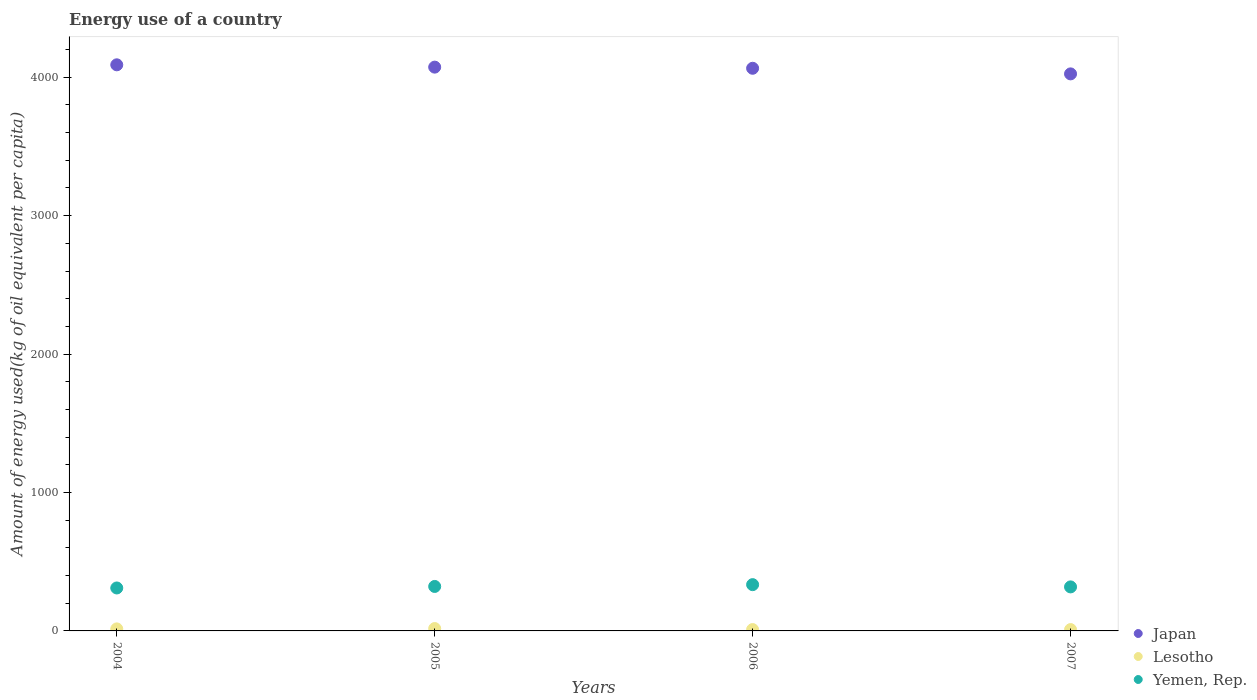How many different coloured dotlines are there?
Your answer should be very brief. 3. Is the number of dotlines equal to the number of legend labels?
Offer a terse response. Yes. What is the amount of energy used in in Lesotho in 2004?
Your answer should be compact. 14.64. Across all years, what is the maximum amount of energy used in in Lesotho?
Offer a terse response. 17.14. Across all years, what is the minimum amount of energy used in in Japan?
Your answer should be very brief. 4024.27. In which year was the amount of energy used in in Lesotho minimum?
Keep it short and to the point. 2007. What is the total amount of energy used in in Yemen, Rep. in the graph?
Your answer should be very brief. 1283.9. What is the difference between the amount of energy used in in Japan in 2005 and that in 2007?
Make the answer very short. 48.74. What is the difference between the amount of energy used in in Yemen, Rep. in 2004 and the amount of energy used in in Japan in 2007?
Your answer should be compact. -3713.97. What is the average amount of energy used in in Yemen, Rep. per year?
Your answer should be very brief. 320.97. In the year 2005, what is the difference between the amount of energy used in in Yemen, Rep. and amount of energy used in in Japan?
Offer a terse response. -3751.74. What is the ratio of the amount of energy used in in Japan in 2004 to that in 2007?
Offer a terse response. 1.02. Is the amount of energy used in in Lesotho in 2004 less than that in 2006?
Provide a short and direct response. No. What is the difference between the highest and the second highest amount of energy used in in Lesotho?
Ensure brevity in your answer.  2.49. What is the difference between the highest and the lowest amount of energy used in in Lesotho?
Give a very brief answer. 7.42. In how many years, is the amount of energy used in in Yemen, Rep. greater than the average amount of energy used in in Yemen, Rep. taken over all years?
Provide a succinct answer. 2. Does the amount of energy used in in Japan monotonically increase over the years?
Your answer should be compact. No. Is the amount of energy used in in Japan strictly greater than the amount of energy used in in Lesotho over the years?
Ensure brevity in your answer.  Yes. How many dotlines are there?
Keep it short and to the point. 3. What is the difference between two consecutive major ticks on the Y-axis?
Make the answer very short. 1000. Are the values on the major ticks of Y-axis written in scientific E-notation?
Offer a very short reply. No. Does the graph contain grids?
Provide a short and direct response. No. Where does the legend appear in the graph?
Your answer should be compact. Bottom right. How many legend labels are there?
Give a very brief answer. 3. What is the title of the graph?
Offer a very short reply. Energy use of a country. Does "Turkey" appear as one of the legend labels in the graph?
Your answer should be very brief. No. What is the label or title of the Y-axis?
Provide a succinct answer. Amount of energy used(kg of oil equivalent per capita). What is the Amount of energy used(kg of oil equivalent per capita) of Japan in 2004?
Offer a terse response. 4089.78. What is the Amount of energy used(kg of oil equivalent per capita) in Lesotho in 2004?
Your answer should be very brief. 14.64. What is the Amount of energy used(kg of oil equivalent per capita) in Yemen, Rep. in 2004?
Your response must be concise. 310.3. What is the Amount of energy used(kg of oil equivalent per capita) in Japan in 2005?
Offer a terse response. 4073.01. What is the Amount of energy used(kg of oil equivalent per capita) in Lesotho in 2005?
Ensure brevity in your answer.  17.14. What is the Amount of energy used(kg of oil equivalent per capita) of Yemen, Rep. in 2005?
Give a very brief answer. 321.27. What is the Amount of energy used(kg of oil equivalent per capita) in Japan in 2006?
Ensure brevity in your answer.  4064.75. What is the Amount of energy used(kg of oil equivalent per capita) of Lesotho in 2006?
Offer a very short reply. 9.79. What is the Amount of energy used(kg of oil equivalent per capita) in Yemen, Rep. in 2006?
Ensure brevity in your answer.  334.32. What is the Amount of energy used(kg of oil equivalent per capita) in Japan in 2007?
Ensure brevity in your answer.  4024.27. What is the Amount of energy used(kg of oil equivalent per capita) of Lesotho in 2007?
Offer a very short reply. 9.72. What is the Amount of energy used(kg of oil equivalent per capita) in Yemen, Rep. in 2007?
Provide a succinct answer. 318.01. Across all years, what is the maximum Amount of energy used(kg of oil equivalent per capita) in Japan?
Your answer should be compact. 4089.78. Across all years, what is the maximum Amount of energy used(kg of oil equivalent per capita) of Lesotho?
Your answer should be very brief. 17.14. Across all years, what is the maximum Amount of energy used(kg of oil equivalent per capita) in Yemen, Rep.?
Make the answer very short. 334.32. Across all years, what is the minimum Amount of energy used(kg of oil equivalent per capita) in Japan?
Your answer should be very brief. 4024.27. Across all years, what is the minimum Amount of energy used(kg of oil equivalent per capita) in Lesotho?
Your response must be concise. 9.72. Across all years, what is the minimum Amount of energy used(kg of oil equivalent per capita) in Yemen, Rep.?
Your answer should be compact. 310.3. What is the total Amount of energy used(kg of oil equivalent per capita) in Japan in the graph?
Offer a very short reply. 1.63e+04. What is the total Amount of energy used(kg of oil equivalent per capita) of Lesotho in the graph?
Offer a very short reply. 51.29. What is the total Amount of energy used(kg of oil equivalent per capita) in Yemen, Rep. in the graph?
Provide a succinct answer. 1283.9. What is the difference between the Amount of energy used(kg of oil equivalent per capita) in Japan in 2004 and that in 2005?
Your response must be concise. 16.77. What is the difference between the Amount of energy used(kg of oil equivalent per capita) in Lesotho in 2004 and that in 2005?
Give a very brief answer. -2.49. What is the difference between the Amount of energy used(kg of oil equivalent per capita) in Yemen, Rep. in 2004 and that in 2005?
Offer a very short reply. -10.97. What is the difference between the Amount of energy used(kg of oil equivalent per capita) of Japan in 2004 and that in 2006?
Your answer should be compact. 25.02. What is the difference between the Amount of energy used(kg of oil equivalent per capita) in Lesotho in 2004 and that in 2006?
Your answer should be very brief. 4.85. What is the difference between the Amount of energy used(kg of oil equivalent per capita) in Yemen, Rep. in 2004 and that in 2006?
Your answer should be compact. -24.02. What is the difference between the Amount of energy used(kg of oil equivalent per capita) of Japan in 2004 and that in 2007?
Ensure brevity in your answer.  65.5. What is the difference between the Amount of energy used(kg of oil equivalent per capita) of Lesotho in 2004 and that in 2007?
Provide a short and direct response. 4.93. What is the difference between the Amount of energy used(kg of oil equivalent per capita) of Yemen, Rep. in 2004 and that in 2007?
Keep it short and to the point. -7.72. What is the difference between the Amount of energy used(kg of oil equivalent per capita) in Japan in 2005 and that in 2006?
Give a very brief answer. 8.25. What is the difference between the Amount of energy used(kg of oil equivalent per capita) of Lesotho in 2005 and that in 2006?
Your answer should be compact. 7.34. What is the difference between the Amount of energy used(kg of oil equivalent per capita) in Yemen, Rep. in 2005 and that in 2006?
Provide a short and direct response. -13.05. What is the difference between the Amount of energy used(kg of oil equivalent per capita) of Japan in 2005 and that in 2007?
Give a very brief answer. 48.74. What is the difference between the Amount of energy used(kg of oil equivalent per capita) in Lesotho in 2005 and that in 2007?
Offer a terse response. 7.42. What is the difference between the Amount of energy used(kg of oil equivalent per capita) in Yemen, Rep. in 2005 and that in 2007?
Offer a very short reply. 3.25. What is the difference between the Amount of energy used(kg of oil equivalent per capita) in Japan in 2006 and that in 2007?
Offer a very short reply. 40.48. What is the difference between the Amount of energy used(kg of oil equivalent per capita) in Lesotho in 2006 and that in 2007?
Make the answer very short. 0.08. What is the difference between the Amount of energy used(kg of oil equivalent per capita) in Yemen, Rep. in 2006 and that in 2007?
Your answer should be very brief. 16.31. What is the difference between the Amount of energy used(kg of oil equivalent per capita) in Japan in 2004 and the Amount of energy used(kg of oil equivalent per capita) in Lesotho in 2005?
Keep it short and to the point. 4072.64. What is the difference between the Amount of energy used(kg of oil equivalent per capita) in Japan in 2004 and the Amount of energy used(kg of oil equivalent per capita) in Yemen, Rep. in 2005?
Keep it short and to the point. 3768.51. What is the difference between the Amount of energy used(kg of oil equivalent per capita) in Lesotho in 2004 and the Amount of energy used(kg of oil equivalent per capita) in Yemen, Rep. in 2005?
Your answer should be compact. -306.62. What is the difference between the Amount of energy used(kg of oil equivalent per capita) in Japan in 2004 and the Amount of energy used(kg of oil equivalent per capita) in Lesotho in 2006?
Keep it short and to the point. 4079.98. What is the difference between the Amount of energy used(kg of oil equivalent per capita) of Japan in 2004 and the Amount of energy used(kg of oil equivalent per capita) of Yemen, Rep. in 2006?
Your answer should be compact. 3755.46. What is the difference between the Amount of energy used(kg of oil equivalent per capita) in Lesotho in 2004 and the Amount of energy used(kg of oil equivalent per capita) in Yemen, Rep. in 2006?
Provide a succinct answer. -319.68. What is the difference between the Amount of energy used(kg of oil equivalent per capita) in Japan in 2004 and the Amount of energy used(kg of oil equivalent per capita) in Lesotho in 2007?
Offer a terse response. 4080.06. What is the difference between the Amount of energy used(kg of oil equivalent per capita) of Japan in 2004 and the Amount of energy used(kg of oil equivalent per capita) of Yemen, Rep. in 2007?
Provide a succinct answer. 3771.76. What is the difference between the Amount of energy used(kg of oil equivalent per capita) in Lesotho in 2004 and the Amount of energy used(kg of oil equivalent per capita) in Yemen, Rep. in 2007?
Provide a short and direct response. -303.37. What is the difference between the Amount of energy used(kg of oil equivalent per capita) of Japan in 2005 and the Amount of energy used(kg of oil equivalent per capita) of Lesotho in 2006?
Offer a very short reply. 4063.22. What is the difference between the Amount of energy used(kg of oil equivalent per capita) in Japan in 2005 and the Amount of energy used(kg of oil equivalent per capita) in Yemen, Rep. in 2006?
Your response must be concise. 3738.69. What is the difference between the Amount of energy used(kg of oil equivalent per capita) in Lesotho in 2005 and the Amount of energy used(kg of oil equivalent per capita) in Yemen, Rep. in 2006?
Give a very brief answer. -317.18. What is the difference between the Amount of energy used(kg of oil equivalent per capita) of Japan in 2005 and the Amount of energy used(kg of oil equivalent per capita) of Lesotho in 2007?
Your response must be concise. 4063.29. What is the difference between the Amount of energy used(kg of oil equivalent per capita) in Japan in 2005 and the Amount of energy used(kg of oil equivalent per capita) in Yemen, Rep. in 2007?
Your response must be concise. 3755. What is the difference between the Amount of energy used(kg of oil equivalent per capita) of Lesotho in 2005 and the Amount of energy used(kg of oil equivalent per capita) of Yemen, Rep. in 2007?
Give a very brief answer. -300.88. What is the difference between the Amount of energy used(kg of oil equivalent per capita) in Japan in 2006 and the Amount of energy used(kg of oil equivalent per capita) in Lesotho in 2007?
Your answer should be compact. 4055.04. What is the difference between the Amount of energy used(kg of oil equivalent per capita) of Japan in 2006 and the Amount of energy used(kg of oil equivalent per capita) of Yemen, Rep. in 2007?
Your response must be concise. 3746.74. What is the difference between the Amount of energy used(kg of oil equivalent per capita) in Lesotho in 2006 and the Amount of energy used(kg of oil equivalent per capita) in Yemen, Rep. in 2007?
Provide a short and direct response. -308.22. What is the average Amount of energy used(kg of oil equivalent per capita) in Japan per year?
Offer a very short reply. 4062.95. What is the average Amount of energy used(kg of oil equivalent per capita) in Lesotho per year?
Provide a succinct answer. 12.82. What is the average Amount of energy used(kg of oil equivalent per capita) of Yemen, Rep. per year?
Your response must be concise. 320.97. In the year 2004, what is the difference between the Amount of energy used(kg of oil equivalent per capita) in Japan and Amount of energy used(kg of oil equivalent per capita) in Lesotho?
Offer a very short reply. 4075.13. In the year 2004, what is the difference between the Amount of energy used(kg of oil equivalent per capita) of Japan and Amount of energy used(kg of oil equivalent per capita) of Yemen, Rep.?
Provide a succinct answer. 3779.48. In the year 2004, what is the difference between the Amount of energy used(kg of oil equivalent per capita) of Lesotho and Amount of energy used(kg of oil equivalent per capita) of Yemen, Rep.?
Give a very brief answer. -295.65. In the year 2005, what is the difference between the Amount of energy used(kg of oil equivalent per capita) of Japan and Amount of energy used(kg of oil equivalent per capita) of Lesotho?
Offer a terse response. 4055.87. In the year 2005, what is the difference between the Amount of energy used(kg of oil equivalent per capita) of Japan and Amount of energy used(kg of oil equivalent per capita) of Yemen, Rep.?
Your answer should be very brief. 3751.74. In the year 2005, what is the difference between the Amount of energy used(kg of oil equivalent per capita) in Lesotho and Amount of energy used(kg of oil equivalent per capita) in Yemen, Rep.?
Keep it short and to the point. -304.13. In the year 2006, what is the difference between the Amount of energy used(kg of oil equivalent per capita) in Japan and Amount of energy used(kg of oil equivalent per capita) in Lesotho?
Keep it short and to the point. 4054.96. In the year 2006, what is the difference between the Amount of energy used(kg of oil equivalent per capita) of Japan and Amount of energy used(kg of oil equivalent per capita) of Yemen, Rep.?
Offer a very short reply. 3730.43. In the year 2006, what is the difference between the Amount of energy used(kg of oil equivalent per capita) in Lesotho and Amount of energy used(kg of oil equivalent per capita) in Yemen, Rep.?
Your response must be concise. -324.53. In the year 2007, what is the difference between the Amount of energy used(kg of oil equivalent per capita) in Japan and Amount of energy used(kg of oil equivalent per capita) in Lesotho?
Offer a terse response. 4014.56. In the year 2007, what is the difference between the Amount of energy used(kg of oil equivalent per capita) in Japan and Amount of energy used(kg of oil equivalent per capita) in Yemen, Rep.?
Provide a short and direct response. 3706.26. In the year 2007, what is the difference between the Amount of energy used(kg of oil equivalent per capita) of Lesotho and Amount of energy used(kg of oil equivalent per capita) of Yemen, Rep.?
Your answer should be compact. -308.3. What is the ratio of the Amount of energy used(kg of oil equivalent per capita) of Lesotho in 2004 to that in 2005?
Your answer should be compact. 0.85. What is the ratio of the Amount of energy used(kg of oil equivalent per capita) in Yemen, Rep. in 2004 to that in 2005?
Provide a short and direct response. 0.97. What is the ratio of the Amount of energy used(kg of oil equivalent per capita) of Japan in 2004 to that in 2006?
Your response must be concise. 1.01. What is the ratio of the Amount of energy used(kg of oil equivalent per capita) of Lesotho in 2004 to that in 2006?
Provide a succinct answer. 1.5. What is the ratio of the Amount of energy used(kg of oil equivalent per capita) of Yemen, Rep. in 2004 to that in 2006?
Give a very brief answer. 0.93. What is the ratio of the Amount of energy used(kg of oil equivalent per capita) of Japan in 2004 to that in 2007?
Keep it short and to the point. 1.02. What is the ratio of the Amount of energy used(kg of oil equivalent per capita) of Lesotho in 2004 to that in 2007?
Provide a short and direct response. 1.51. What is the ratio of the Amount of energy used(kg of oil equivalent per capita) of Yemen, Rep. in 2004 to that in 2007?
Ensure brevity in your answer.  0.98. What is the ratio of the Amount of energy used(kg of oil equivalent per capita) in Lesotho in 2005 to that in 2006?
Your response must be concise. 1.75. What is the ratio of the Amount of energy used(kg of oil equivalent per capita) in Japan in 2005 to that in 2007?
Your answer should be very brief. 1.01. What is the ratio of the Amount of energy used(kg of oil equivalent per capita) in Lesotho in 2005 to that in 2007?
Your answer should be compact. 1.76. What is the ratio of the Amount of energy used(kg of oil equivalent per capita) in Yemen, Rep. in 2005 to that in 2007?
Your answer should be very brief. 1.01. What is the ratio of the Amount of energy used(kg of oil equivalent per capita) of Lesotho in 2006 to that in 2007?
Provide a succinct answer. 1.01. What is the ratio of the Amount of energy used(kg of oil equivalent per capita) in Yemen, Rep. in 2006 to that in 2007?
Offer a terse response. 1.05. What is the difference between the highest and the second highest Amount of energy used(kg of oil equivalent per capita) in Japan?
Offer a very short reply. 16.77. What is the difference between the highest and the second highest Amount of energy used(kg of oil equivalent per capita) of Lesotho?
Your answer should be compact. 2.49. What is the difference between the highest and the second highest Amount of energy used(kg of oil equivalent per capita) in Yemen, Rep.?
Offer a very short reply. 13.05. What is the difference between the highest and the lowest Amount of energy used(kg of oil equivalent per capita) of Japan?
Keep it short and to the point. 65.5. What is the difference between the highest and the lowest Amount of energy used(kg of oil equivalent per capita) in Lesotho?
Keep it short and to the point. 7.42. What is the difference between the highest and the lowest Amount of energy used(kg of oil equivalent per capita) in Yemen, Rep.?
Your answer should be compact. 24.02. 